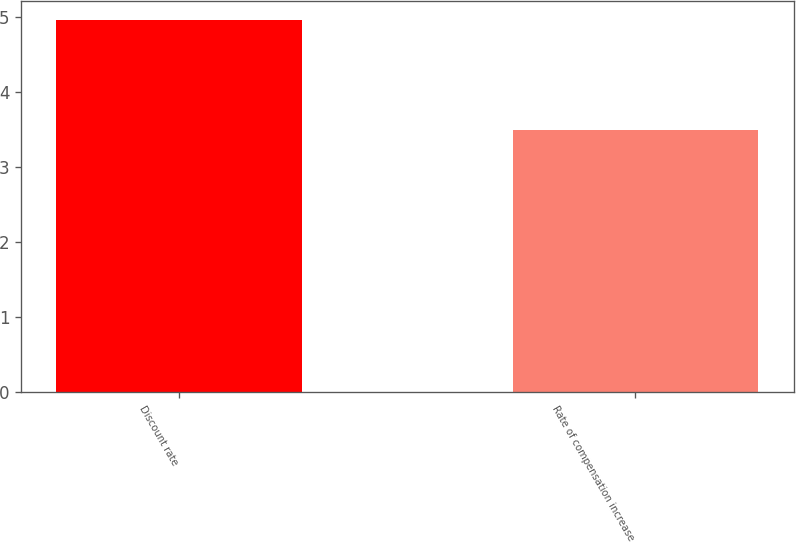<chart> <loc_0><loc_0><loc_500><loc_500><bar_chart><fcel>Discount rate<fcel>Rate of compensation increase<nl><fcel>4.97<fcel>3.5<nl></chart> 